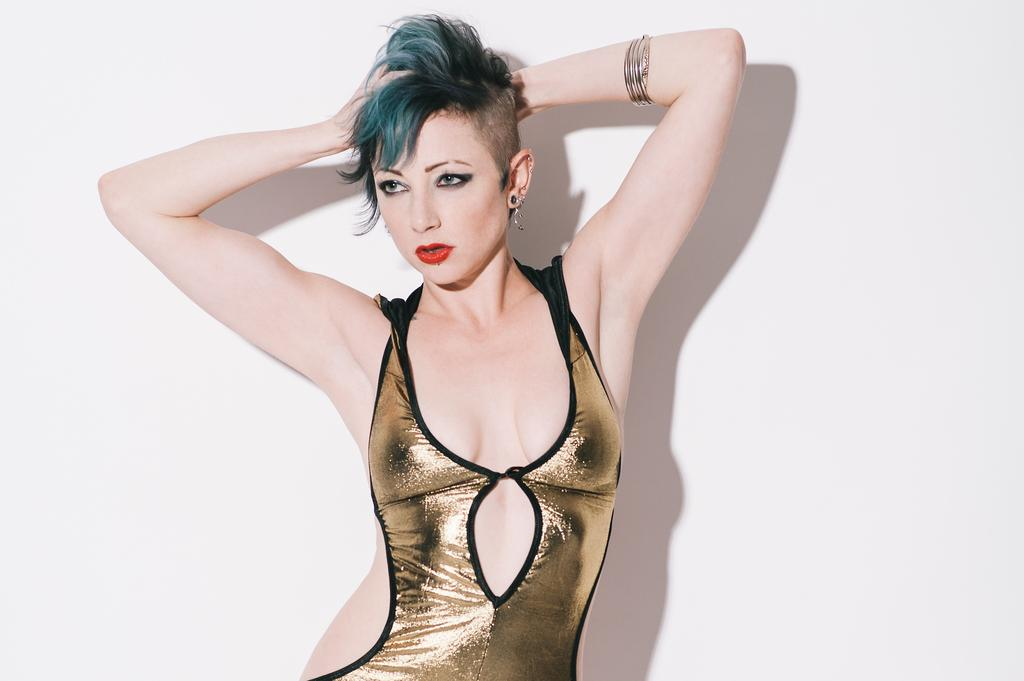Who is the main subject in the image? There is a woman in the image. Can you describe the woman's position in the image? The woman is standing in the front. What is the woman wearing in the image? The woman is wearing a golden color dress. What can be seen in the background of the image? There is a shadow of the woman and a wall visible in the background. What theory does the stranger in the image propose about the wall? There is no stranger present in the image, and therefore no theory about the wall can be discussed. 